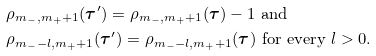<formula> <loc_0><loc_0><loc_500><loc_500>& \rho _ { m _ { - } , m _ { + } + 1 } ( { \boldsymbol \tau } ^ { \prime } ) = \rho _ { m _ { - } , m _ { + } + 1 } ( { \boldsymbol \tau } ) - 1 \text { and } \\ & \rho _ { m _ { - } - l , m _ { + } + 1 } ( { \boldsymbol \tau } ^ { \prime } ) = \rho _ { m _ { - } - l , m _ { + } + 1 } ( { \boldsymbol \tau } ) \text { for every } l > 0 .</formula> 